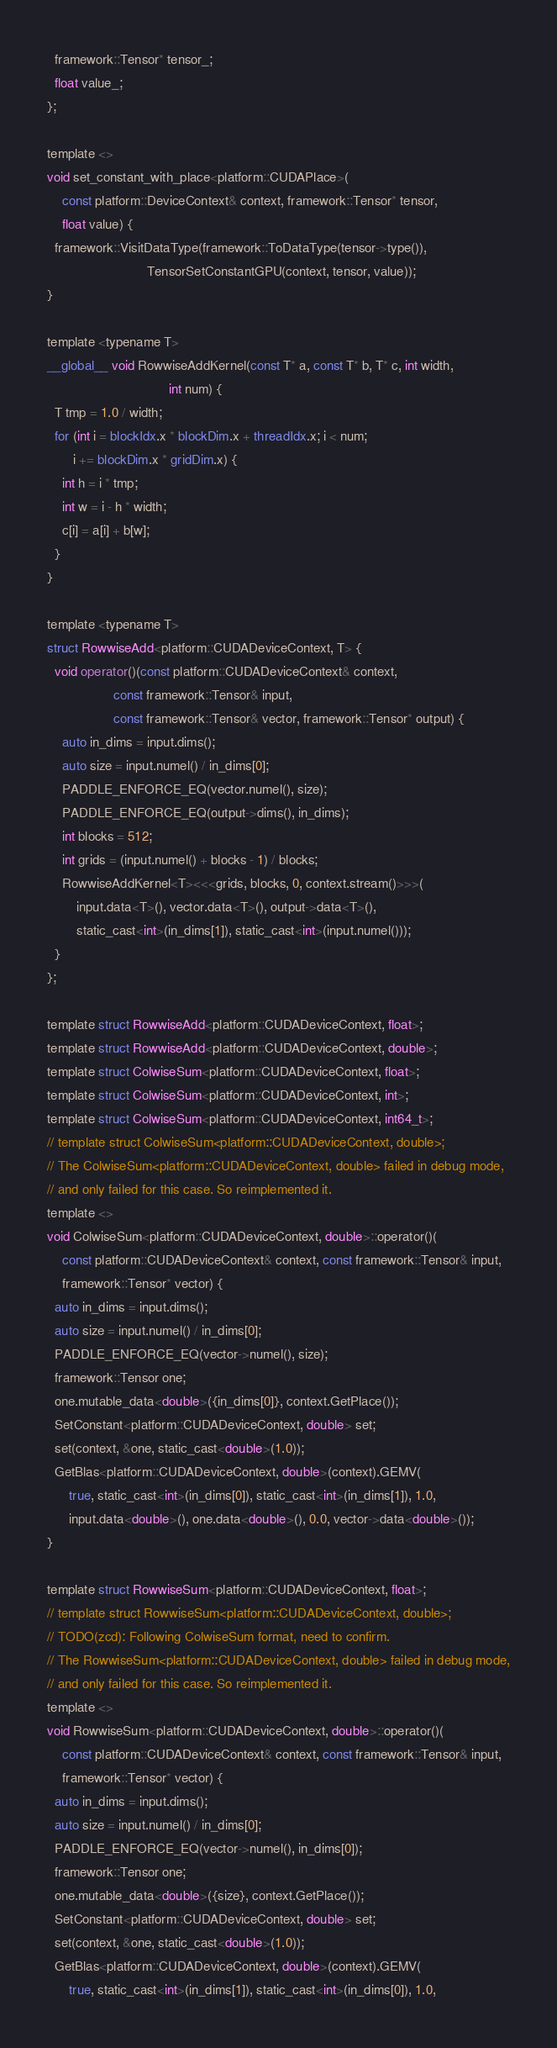<code> <loc_0><loc_0><loc_500><loc_500><_Cuda_>  framework::Tensor* tensor_;
  float value_;
};

template <>
void set_constant_with_place<platform::CUDAPlace>(
    const platform::DeviceContext& context, framework::Tensor* tensor,
    float value) {
  framework::VisitDataType(framework::ToDataType(tensor->type()),
                           TensorSetConstantGPU(context, tensor, value));
}

template <typename T>
__global__ void RowwiseAddKernel(const T* a, const T* b, T* c, int width,
                                 int num) {
  T tmp = 1.0 / width;
  for (int i = blockIdx.x * blockDim.x + threadIdx.x; i < num;
       i += blockDim.x * gridDim.x) {
    int h = i * tmp;
    int w = i - h * width;
    c[i] = a[i] + b[w];
  }
}

template <typename T>
struct RowwiseAdd<platform::CUDADeviceContext, T> {
  void operator()(const platform::CUDADeviceContext& context,
                  const framework::Tensor& input,
                  const framework::Tensor& vector, framework::Tensor* output) {
    auto in_dims = input.dims();
    auto size = input.numel() / in_dims[0];
    PADDLE_ENFORCE_EQ(vector.numel(), size);
    PADDLE_ENFORCE_EQ(output->dims(), in_dims);
    int blocks = 512;
    int grids = (input.numel() + blocks - 1) / blocks;
    RowwiseAddKernel<T><<<grids, blocks, 0, context.stream()>>>(
        input.data<T>(), vector.data<T>(), output->data<T>(),
        static_cast<int>(in_dims[1]), static_cast<int>(input.numel()));
  }
};

template struct RowwiseAdd<platform::CUDADeviceContext, float>;
template struct RowwiseAdd<platform::CUDADeviceContext, double>;
template struct ColwiseSum<platform::CUDADeviceContext, float>;
template struct ColwiseSum<platform::CUDADeviceContext, int>;
template struct ColwiseSum<platform::CUDADeviceContext, int64_t>;
// template struct ColwiseSum<platform::CUDADeviceContext, double>;
// The ColwiseSum<platform::CUDADeviceContext, double> failed in debug mode,
// and only failed for this case. So reimplemented it.
template <>
void ColwiseSum<platform::CUDADeviceContext, double>::operator()(
    const platform::CUDADeviceContext& context, const framework::Tensor& input,
    framework::Tensor* vector) {
  auto in_dims = input.dims();
  auto size = input.numel() / in_dims[0];
  PADDLE_ENFORCE_EQ(vector->numel(), size);
  framework::Tensor one;
  one.mutable_data<double>({in_dims[0]}, context.GetPlace());
  SetConstant<platform::CUDADeviceContext, double> set;
  set(context, &one, static_cast<double>(1.0));
  GetBlas<platform::CUDADeviceContext, double>(context).GEMV(
      true, static_cast<int>(in_dims[0]), static_cast<int>(in_dims[1]), 1.0,
      input.data<double>(), one.data<double>(), 0.0, vector->data<double>());
}

template struct RowwiseSum<platform::CUDADeviceContext, float>;
// template struct RowwiseSum<platform::CUDADeviceContext, double>;
// TODO(zcd): Following ColwiseSum format, need to confirm.
// The RowwiseSum<platform::CUDADeviceContext, double> failed in debug mode,
// and only failed for this case. So reimplemented it.
template <>
void RowwiseSum<platform::CUDADeviceContext, double>::operator()(
    const platform::CUDADeviceContext& context, const framework::Tensor& input,
    framework::Tensor* vector) {
  auto in_dims = input.dims();
  auto size = input.numel() / in_dims[0];
  PADDLE_ENFORCE_EQ(vector->numel(), in_dims[0]);
  framework::Tensor one;
  one.mutable_data<double>({size}, context.GetPlace());
  SetConstant<platform::CUDADeviceContext, double> set;
  set(context, &one, static_cast<double>(1.0));
  GetBlas<platform::CUDADeviceContext, double>(context).GEMV(
      true, static_cast<int>(in_dims[1]), static_cast<int>(in_dims[0]), 1.0,</code> 